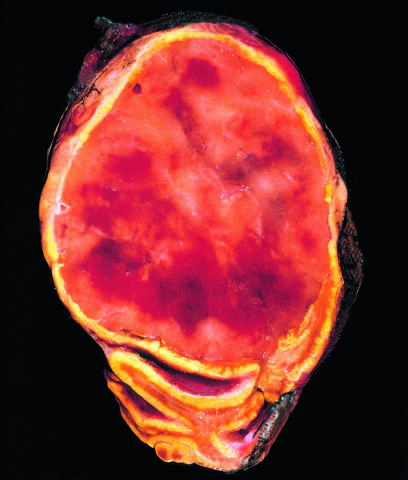what are not visible in this preparation?
Answer the question using a single word or phrase. Granules containing catecholamine 